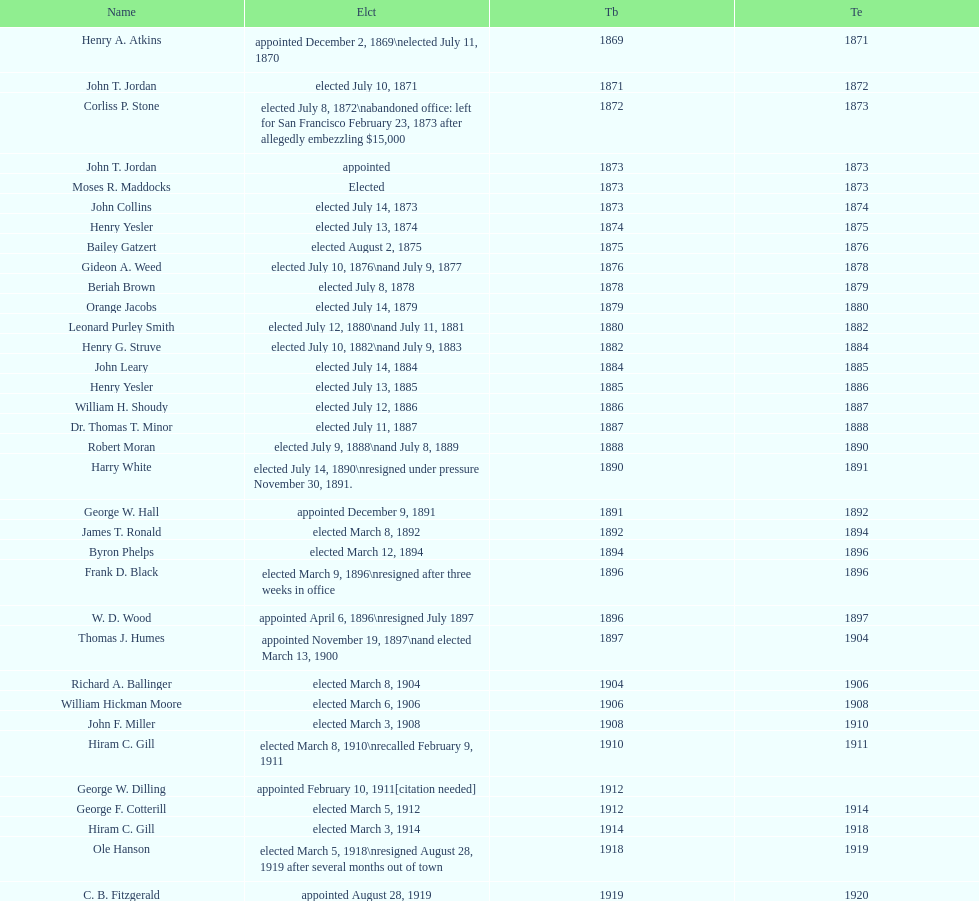Who was the mayor before jordan? Henry A. Atkins. 